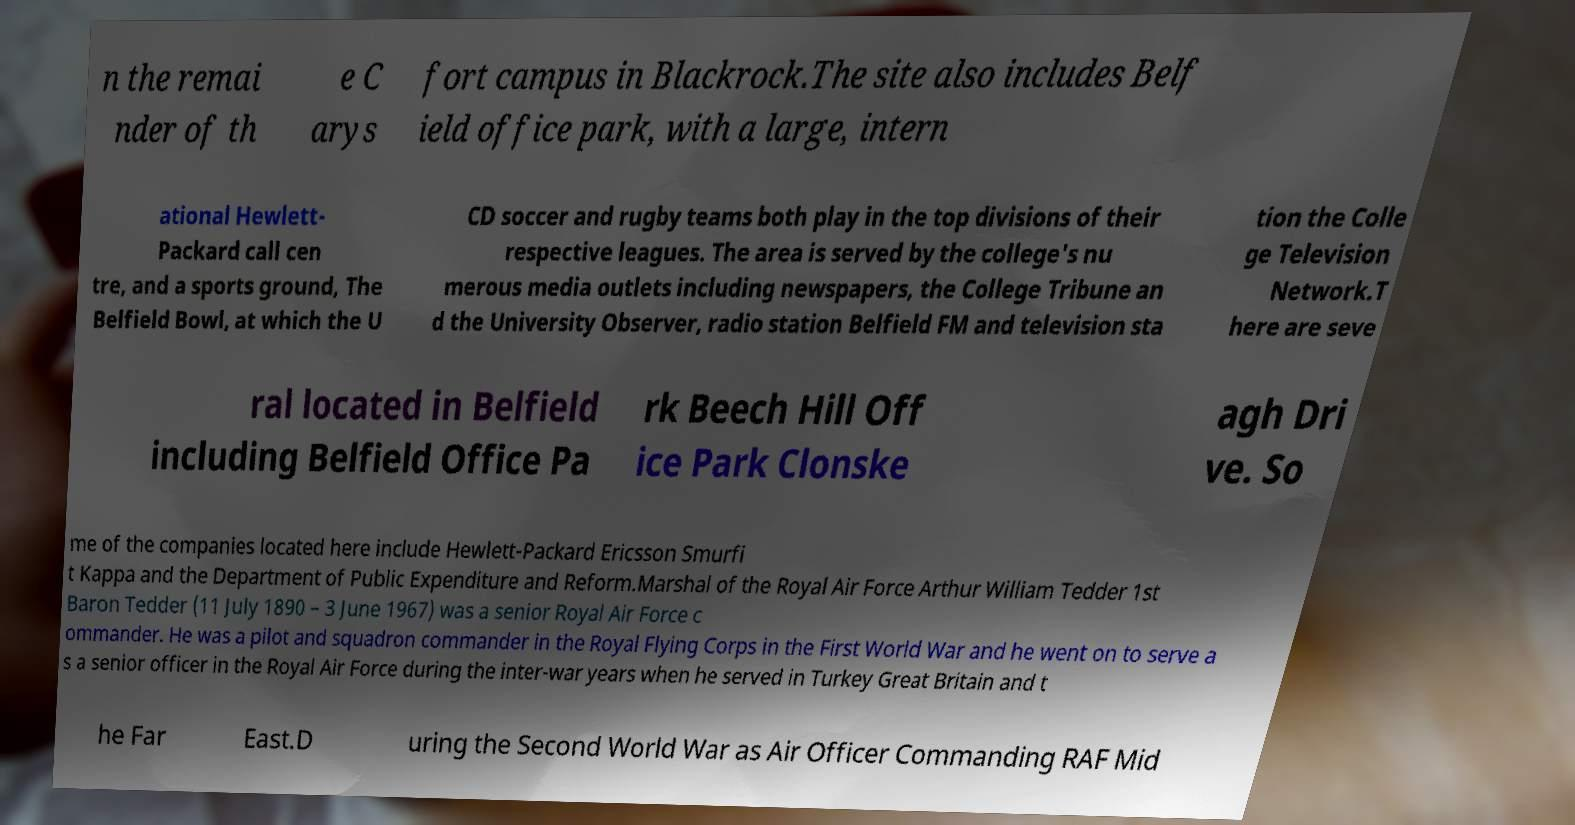There's text embedded in this image that I need extracted. Can you transcribe it verbatim? n the remai nder of th e C arys fort campus in Blackrock.The site also includes Belf ield office park, with a large, intern ational Hewlett- Packard call cen tre, and a sports ground, The Belfield Bowl, at which the U CD soccer and rugby teams both play in the top divisions of their respective leagues. The area is served by the college's nu merous media outlets including newspapers, the College Tribune an d the University Observer, radio station Belfield FM and television sta tion the Colle ge Television Network.T here are seve ral located in Belfield including Belfield Office Pa rk Beech Hill Off ice Park Clonske agh Dri ve. So me of the companies located here include Hewlett-Packard Ericsson Smurfi t Kappa and the Department of Public Expenditure and Reform.Marshal of the Royal Air Force Arthur William Tedder 1st Baron Tedder (11 July 1890 – 3 June 1967) was a senior Royal Air Force c ommander. He was a pilot and squadron commander in the Royal Flying Corps in the First World War and he went on to serve a s a senior officer in the Royal Air Force during the inter-war years when he served in Turkey Great Britain and t he Far East.D uring the Second World War as Air Officer Commanding RAF Mid 